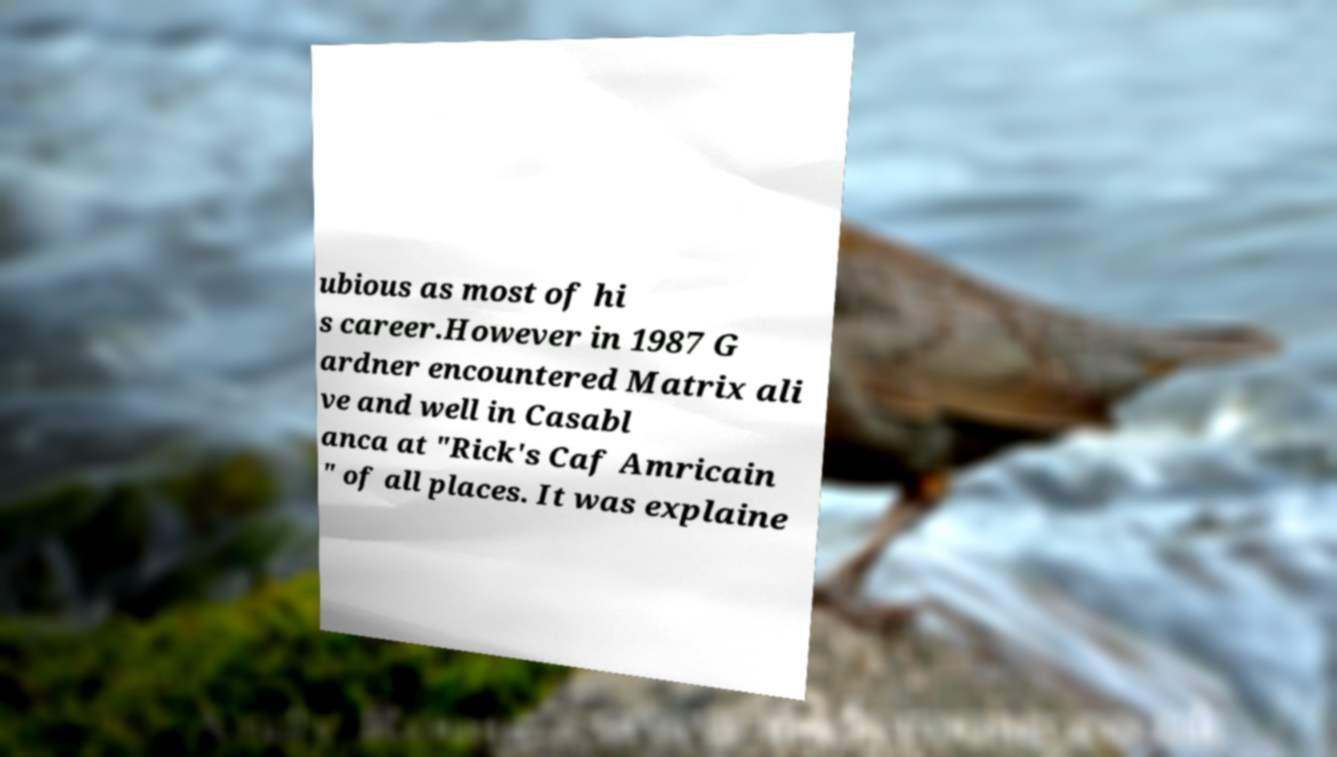What messages or text are displayed in this image? I need them in a readable, typed format. ubious as most of hi s career.However in 1987 G ardner encountered Matrix ali ve and well in Casabl anca at "Rick's Caf Amricain " of all places. It was explaine 